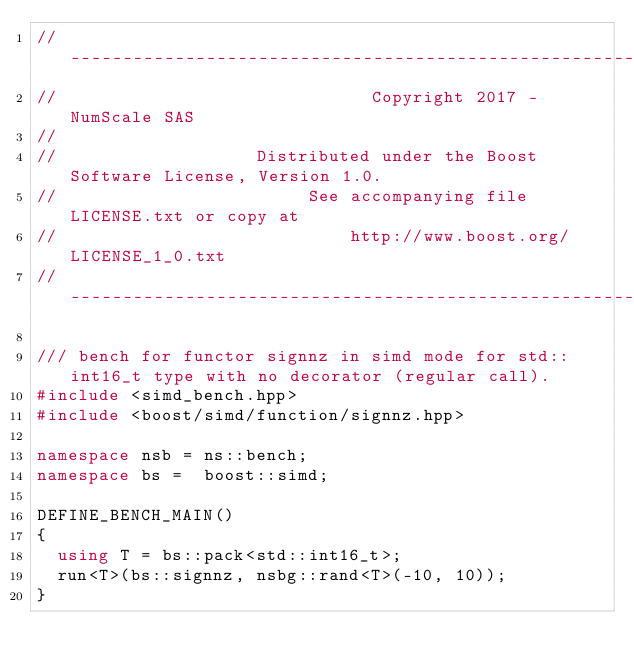Convert code to text. <code><loc_0><loc_0><loc_500><loc_500><_C++_>// -------------------------------------------------------------------------------------------------
//                              Copyright 2017 - NumScale SAS
//
//                   Distributed under the Boost Software License, Version 1.0.
//                        See accompanying file LICENSE.txt or copy at
//                            http://www.boost.org/LICENSE_1_0.txt
// -------------------------------------------------------------------------------------------------

/// bench for functor signnz in simd mode for std::int16_t type with no decorator (regular call).
#include <simd_bench.hpp>
#include <boost/simd/function/signnz.hpp>

namespace nsb = ns::bench;
namespace bs =  boost::simd;

DEFINE_BENCH_MAIN()
{
  using T = bs::pack<std::int16_t>;
  run<T>(bs::signnz, nsbg::rand<T>(-10, 10));
}

</code> 